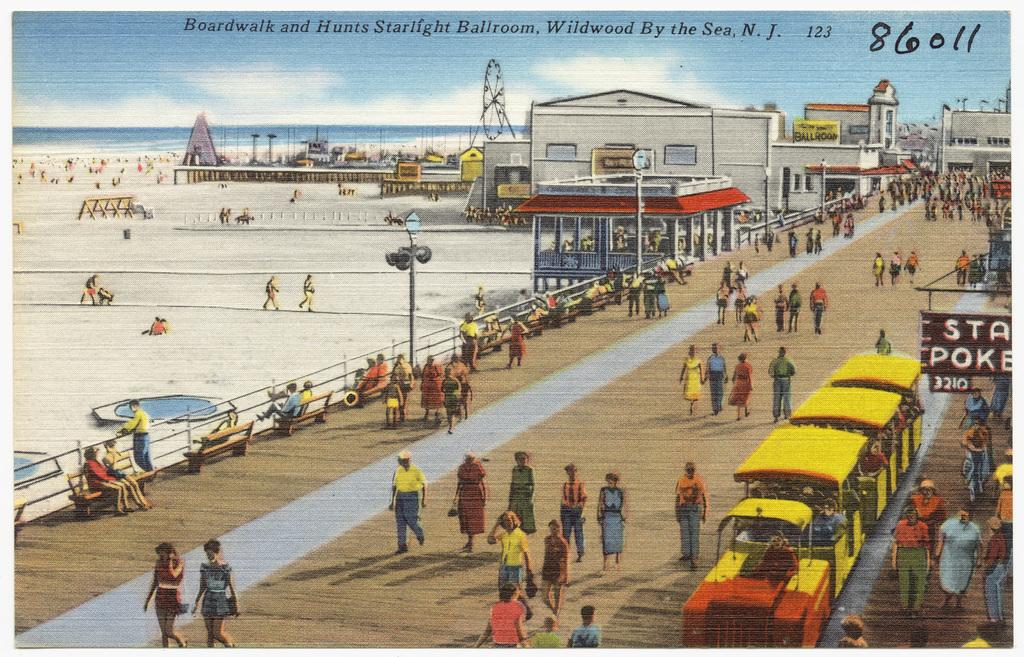<image>
Create a compact narrative representing the image presented. an illustrated image of a boardwalk by the beach with the numberf 86011 on the top right side. 